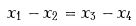Convert formula to latex. <formula><loc_0><loc_0><loc_500><loc_500>x _ { 1 } - x _ { 2 } = x _ { 3 } - x _ { 4 }</formula> 